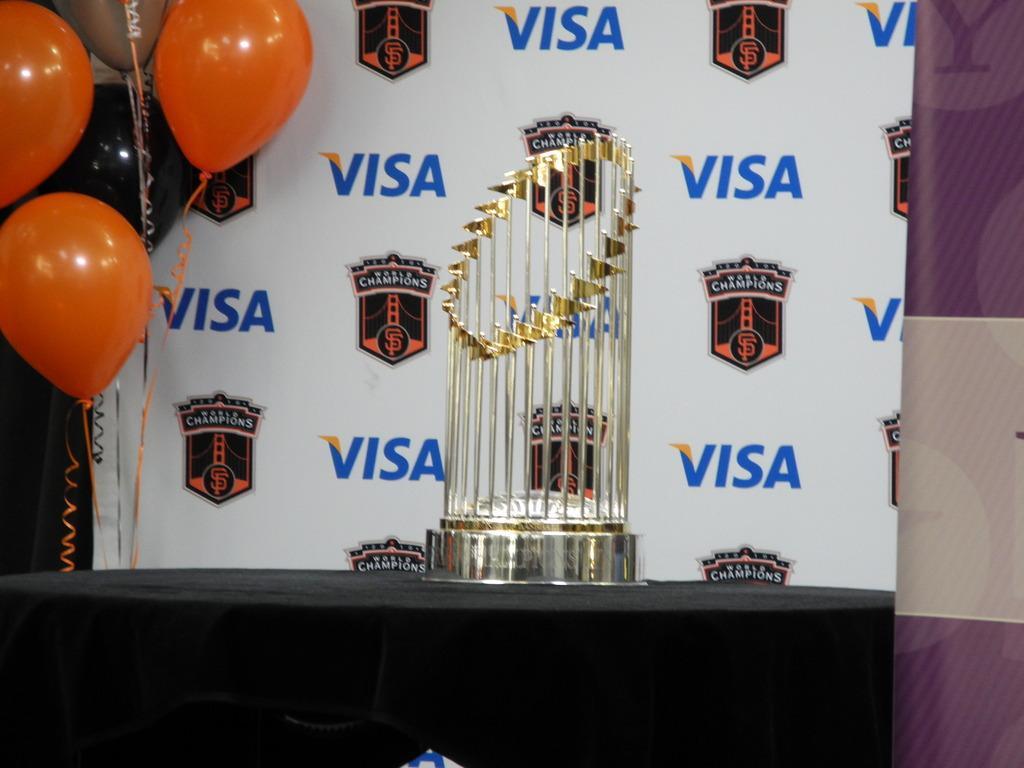In one or two sentences, can you explain what this image depicts? At the bottom of the image we can see a table. On the table we can see a cloth and trophy. In the background of the image we can see the wall, board and balloons. 